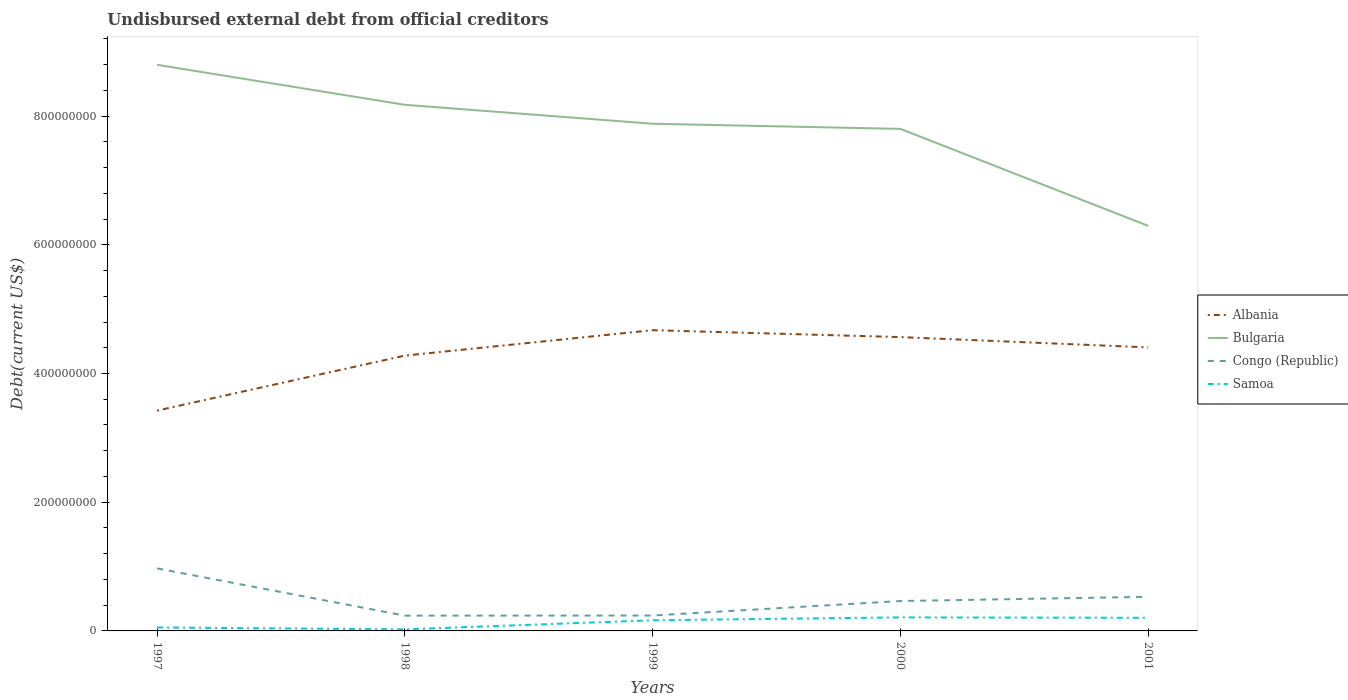Is the number of lines equal to the number of legend labels?
Your response must be concise. Yes. Across all years, what is the maximum total debt in Albania?
Provide a succinct answer. 3.42e+08. What is the total total debt in Bulgaria in the graph?
Make the answer very short. 6.22e+07. What is the difference between the highest and the second highest total debt in Albania?
Keep it short and to the point. 1.25e+08. What is the difference between the highest and the lowest total debt in Samoa?
Your answer should be compact. 3. How many lines are there?
Offer a very short reply. 4. How many years are there in the graph?
Provide a succinct answer. 5. Does the graph contain any zero values?
Your answer should be compact. No. Where does the legend appear in the graph?
Give a very brief answer. Center right. What is the title of the graph?
Make the answer very short. Undisbursed external debt from official creditors. Does "San Marino" appear as one of the legend labels in the graph?
Offer a terse response. No. What is the label or title of the Y-axis?
Provide a short and direct response. Debt(current US$). What is the Debt(current US$) of Albania in 1997?
Your response must be concise. 3.42e+08. What is the Debt(current US$) in Bulgaria in 1997?
Ensure brevity in your answer.  8.80e+08. What is the Debt(current US$) of Congo (Republic) in 1997?
Offer a terse response. 9.72e+07. What is the Debt(current US$) in Samoa in 1997?
Offer a very short reply. 5.40e+06. What is the Debt(current US$) of Albania in 1998?
Your answer should be very brief. 4.28e+08. What is the Debt(current US$) in Bulgaria in 1998?
Make the answer very short. 8.18e+08. What is the Debt(current US$) of Congo (Republic) in 1998?
Give a very brief answer. 2.37e+07. What is the Debt(current US$) in Samoa in 1998?
Your answer should be very brief. 2.42e+06. What is the Debt(current US$) of Albania in 1999?
Give a very brief answer. 4.67e+08. What is the Debt(current US$) in Bulgaria in 1999?
Make the answer very short. 7.88e+08. What is the Debt(current US$) in Congo (Republic) in 1999?
Your response must be concise. 2.40e+07. What is the Debt(current US$) in Samoa in 1999?
Offer a terse response. 1.66e+07. What is the Debt(current US$) of Albania in 2000?
Offer a terse response. 4.57e+08. What is the Debt(current US$) of Bulgaria in 2000?
Provide a succinct answer. 7.80e+08. What is the Debt(current US$) in Congo (Republic) in 2000?
Make the answer very short. 4.64e+07. What is the Debt(current US$) in Samoa in 2000?
Provide a short and direct response. 2.10e+07. What is the Debt(current US$) in Albania in 2001?
Ensure brevity in your answer.  4.41e+08. What is the Debt(current US$) in Bulgaria in 2001?
Your response must be concise. 6.29e+08. What is the Debt(current US$) in Congo (Republic) in 2001?
Offer a very short reply. 5.30e+07. What is the Debt(current US$) in Samoa in 2001?
Your answer should be compact. 2.04e+07. Across all years, what is the maximum Debt(current US$) of Albania?
Your answer should be very brief. 4.67e+08. Across all years, what is the maximum Debt(current US$) in Bulgaria?
Your answer should be compact. 8.80e+08. Across all years, what is the maximum Debt(current US$) in Congo (Republic)?
Give a very brief answer. 9.72e+07. Across all years, what is the maximum Debt(current US$) in Samoa?
Keep it short and to the point. 2.10e+07. Across all years, what is the minimum Debt(current US$) in Albania?
Provide a short and direct response. 3.42e+08. Across all years, what is the minimum Debt(current US$) in Bulgaria?
Keep it short and to the point. 6.29e+08. Across all years, what is the minimum Debt(current US$) of Congo (Republic)?
Make the answer very short. 2.37e+07. Across all years, what is the minimum Debt(current US$) in Samoa?
Keep it short and to the point. 2.42e+06. What is the total Debt(current US$) of Albania in the graph?
Provide a short and direct response. 2.13e+09. What is the total Debt(current US$) of Bulgaria in the graph?
Provide a short and direct response. 3.89e+09. What is the total Debt(current US$) in Congo (Republic) in the graph?
Make the answer very short. 2.44e+08. What is the total Debt(current US$) in Samoa in the graph?
Offer a terse response. 6.58e+07. What is the difference between the Debt(current US$) of Albania in 1997 and that in 1998?
Make the answer very short. -8.54e+07. What is the difference between the Debt(current US$) in Bulgaria in 1997 and that in 1998?
Keep it short and to the point. 6.22e+07. What is the difference between the Debt(current US$) of Congo (Republic) in 1997 and that in 1998?
Make the answer very short. 7.34e+07. What is the difference between the Debt(current US$) in Samoa in 1997 and that in 1998?
Your answer should be compact. 2.98e+06. What is the difference between the Debt(current US$) in Albania in 1997 and that in 1999?
Your answer should be compact. -1.25e+08. What is the difference between the Debt(current US$) in Bulgaria in 1997 and that in 1999?
Keep it short and to the point. 9.16e+07. What is the difference between the Debt(current US$) in Congo (Republic) in 1997 and that in 1999?
Your answer should be very brief. 7.32e+07. What is the difference between the Debt(current US$) in Samoa in 1997 and that in 1999?
Your answer should be compact. -1.12e+07. What is the difference between the Debt(current US$) in Albania in 1997 and that in 2000?
Provide a short and direct response. -1.14e+08. What is the difference between the Debt(current US$) of Bulgaria in 1997 and that in 2000?
Your response must be concise. 9.96e+07. What is the difference between the Debt(current US$) in Congo (Republic) in 1997 and that in 2000?
Keep it short and to the point. 5.07e+07. What is the difference between the Debt(current US$) of Samoa in 1997 and that in 2000?
Your response must be concise. -1.56e+07. What is the difference between the Debt(current US$) in Albania in 1997 and that in 2001?
Provide a short and direct response. -9.82e+07. What is the difference between the Debt(current US$) in Bulgaria in 1997 and that in 2001?
Offer a very short reply. 2.50e+08. What is the difference between the Debt(current US$) of Congo (Republic) in 1997 and that in 2001?
Offer a terse response. 4.41e+07. What is the difference between the Debt(current US$) in Samoa in 1997 and that in 2001?
Offer a very short reply. -1.50e+07. What is the difference between the Debt(current US$) in Albania in 1998 and that in 1999?
Your response must be concise. -3.95e+07. What is the difference between the Debt(current US$) of Bulgaria in 1998 and that in 1999?
Provide a succinct answer. 2.94e+07. What is the difference between the Debt(current US$) of Congo (Republic) in 1998 and that in 1999?
Ensure brevity in your answer.  -2.22e+05. What is the difference between the Debt(current US$) of Samoa in 1998 and that in 1999?
Keep it short and to the point. -1.41e+07. What is the difference between the Debt(current US$) of Albania in 1998 and that in 2000?
Your answer should be very brief. -2.88e+07. What is the difference between the Debt(current US$) in Bulgaria in 1998 and that in 2000?
Offer a very short reply. 3.74e+07. What is the difference between the Debt(current US$) of Congo (Republic) in 1998 and that in 2000?
Provide a succinct answer. -2.27e+07. What is the difference between the Debt(current US$) in Samoa in 1998 and that in 2000?
Provide a short and direct response. -1.86e+07. What is the difference between the Debt(current US$) in Albania in 1998 and that in 2001?
Ensure brevity in your answer.  -1.28e+07. What is the difference between the Debt(current US$) in Bulgaria in 1998 and that in 2001?
Give a very brief answer. 1.88e+08. What is the difference between the Debt(current US$) of Congo (Republic) in 1998 and that in 2001?
Offer a very short reply. -2.93e+07. What is the difference between the Debt(current US$) in Samoa in 1998 and that in 2001?
Ensure brevity in your answer.  -1.80e+07. What is the difference between the Debt(current US$) in Albania in 1999 and that in 2000?
Make the answer very short. 1.07e+07. What is the difference between the Debt(current US$) of Bulgaria in 1999 and that in 2000?
Give a very brief answer. 8.00e+06. What is the difference between the Debt(current US$) of Congo (Republic) in 1999 and that in 2000?
Your answer should be very brief. -2.25e+07. What is the difference between the Debt(current US$) of Samoa in 1999 and that in 2000?
Your answer should be compact. -4.47e+06. What is the difference between the Debt(current US$) of Albania in 1999 and that in 2001?
Ensure brevity in your answer.  2.67e+07. What is the difference between the Debt(current US$) of Bulgaria in 1999 and that in 2001?
Make the answer very short. 1.59e+08. What is the difference between the Debt(current US$) in Congo (Republic) in 1999 and that in 2001?
Your answer should be compact. -2.91e+07. What is the difference between the Debt(current US$) of Samoa in 1999 and that in 2001?
Make the answer very short. -3.84e+06. What is the difference between the Debt(current US$) in Albania in 2000 and that in 2001?
Offer a terse response. 1.60e+07. What is the difference between the Debt(current US$) of Bulgaria in 2000 and that in 2001?
Your response must be concise. 1.51e+08. What is the difference between the Debt(current US$) in Congo (Republic) in 2000 and that in 2001?
Give a very brief answer. -6.60e+06. What is the difference between the Debt(current US$) of Samoa in 2000 and that in 2001?
Your response must be concise. 6.26e+05. What is the difference between the Debt(current US$) of Albania in 1997 and the Debt(current US$) of Bulgaria in 1998?
Make the answer very short. -4.75e+08. What is the difference between the Debt(current US$) in Albania in 1997 and the Debt(current US$) in Congo (Republic) in 1998?
Your answer should be compact. 3.19e+08. What is the difference between the Debt(current US$) in Albania in 1997 and the Debt(current US$) in Samoa in 1998?
Ensure brevity in your answer.  3.40e+08. What is the difference between the Debt(current US$) in Bulgaria in 1997 and the Debt(current US$) in Congo (Republic) in 1998?
Keep it short and to the point. 8.56e+08. What is the difference between the Debt(current US$) in Bulgaria in 1997 and the Debt(current US$) in Samoa in 1998?
Your answer should be very brief. 8.77e+08. What is the difference between the Debt(current US$) in Congo (Republic) in 1997 and the Debt(current US$) in Samoa in 1998?
Make the answer very short. 9.48e+07. What is the difference between the Debt(current US$) in Albania in 1997 and the Debt(current US$) in Bulgaria in 1999?
Your answer should be very brief. -4.46e+08. What is the difference between the Debt(current US$) in Albania in 1997 and the Debt(current US$) in Congo (Republic) in 1999?
Make the answer very short. 3.18e+08. What is the difference between the Debt(current US$) of Albania in 1997 and the Debt(current US$) of Samoa in 1999?
Your response must be concise. 3.26e+08. What is the difference between the Debt(current US$) in Bulgaria in 1997 and the Debt(current US$) in Congo (Republic) in 1999?
Ensure brevity in your answer.  8.56e+08. What is the difference between the Debt(current US$) in Bulgaria in 1997 and the Debt(current US$) in Samoa in 1999?
Keep it short and to the point. 8.63e+08. What is the difference between the Debt(current US$) of Congo (Republic) in 1997 and the Debt(current US$) of Samoa in 1999?
Your response must be concise. 8.06e+07. What is the difference between the Debt(current US$) in Albania in 1997 and the Debt(current US$) in Bulgaria in 2000?
Keep it short and to the point. -4.38e+08. What is the difference between the Debt(current US$) of Albania in 1997 and the Debt(current US$) of Congo (Republic) in 2000?
Offer a terse response. 2.96e+08. What is the difference between the Debt(current US$) of Albania in 1997 and the Debt(current US$) of Samoa in 2000?
Provide a succinct answer. 3.21e+08. What is the difference between the Debt(current US$) in Bulgaria in 1997 and the Debt(current US$) in Congo (Republic) in 2000?
Your response must be concise. 8.33e+08. What is the difference between the Debt(current US$) in Bulgaria in 1997 and the Debt(current US$) in Samoa in 2000?
Provide a short and direct response. 8.59e+08. What is the difference between the Debt(current US$) of Congo (Republic) in 1997 and the Debt(current US$) of Samoa in 2000?
Make the answer very short. 7.61e+07. What is the difference between the Debt(current US$) in Albania in 1997 and the Debt(current US$) in Bulgaria in 2001?
Provide a succinct answer. -2.87e+08. What is the difference between the Debt(current US$) in Albania in 1997 and the Debt(current US$) in Congo (Republic) in 2001?
Ensure brevity in your answer.  2.89e+08. What is the difference between the Debt(current US$) in Albania in 1997 and the Debt(current US$) in Samoa in 2001?
Make the answer very short. 3.22e+08. What is the difference between the Debt(current US$) in Bulgaria in 1997 and the Debt(current US$) in Congo (Republic) in 2001?
Keep it short and to the point. 8.27e+08. What is the difference between the Debt(current US$) in Bulgaria in 1997 and the Debt(current US$) in Samoa in 2001?
Provide a short and direct response. 8.59e+08. What is the difference between the Debt(current US$) of Congo (Republic) in 1997 and the Debt(current US$) of Samoa in 2001?
Make the answer very short. 7.68e+07. What is the difference between the Debt(current US$) in Albania in 1998 and the Debt(current US$) in Bulgaria in 1999?
Your response must be concise. -3.60e+08. What is the difference between the Debt(current US$) of Albania in 1998 and the Debt(current US$) of Congo (Republic) in 1999?
Your answer should be compact. 4.04e+08. What is the difference between the Debt(current US$) of Albania in 1998 and the Debt(current US$) of Samoa in 1999?
Your response must be concise. 4.11e+08. What is the difference between the Debt(current US$) of Bulgaria in 1998 and the Debt(current US$) of Congo (Republic) in 1999?
Offer a very short reply. 7.94e+08. What is the difference between the Debt(current US$) of Bulgaria in 1998 and the Debt(current US$) of Samoa in 1999?
Offer a terse response. 8.01e+08. What is the difference between the Debt(current US$) in Congo (Republic) in 1998 and the Debt(current US$) in Samoa in 1999?
Provide a succinct answer. 7.18e+06. What is the difference between the Debt(current US$) in Albania in 1998 and the Debt(current US$) in Bulgaria in 2000?
Offer a terse response. -3.52e+08. What is the difference between the Debt(current US$) of Albania in 1998 and the Debt(current US$) of Congo (Republic) in 2000?
Your answer should be compact. 3.81e+08. What is the difference between the Debt(current US$) of Albania in 1998 and the Debt(current US$) of Samoa in 2000?
Your answer should be compact. 4.07e+08. What is the difference between the Debt(current US$) of Bulgaria in 1998 and the Debt(current US$) of Congo (Republic) in 2000?
Offer a very short reply. 7.71e+08. What is the difference between the Debt(current US$) in Bulgaria in 1998 and the Debt(current US$) in Samoa in 2000?
Your response must be concise. 7.97e+08. What is the difference between the Debt(current US$) of Congo (Republic) in 1998 and the Debt(current US$) of Samoa in 2000?
Your answer should be compact. 2.72e+06. What is the difference between the Debt(current US$) in Albania in 1998 and the Debt(current US$) in Bulgaria in 2001?
Ensure brevity in your answer.  -2.02e+08. What is the difference between the Debt(current US$) of Albania in 1998 and the Debt(current US$) of Congo (Republic) in 2001?
Offer a terse response. 3.75e+08. What is the difference between the Debt(current US$) of Albania in 1998 and the Debt(current US$) of Samoa in 2001?
Make the answer very short. 4.07e+08. What is the difference between the Debt(current US$) of Bulgaria in 1998 and the Debt(current US$) of Congo (Republic) in 2001?
Keep it short and to the point. 7.65e+08. What is the difference between the Debt(current US$) in Bulgaria in 1998 and the Debt(current US$) in Samoa in 2001?
Keep it short and to the point. 7.97e+08. What is the difference between the Debt(current US$) in Congo (Republic) in 1998 and the Debt(current US$) in Samoa in 2001?
Keep it short and to the point. 3.34e+06. What is the difference between the Debt(current US$) in Albania in 1999 and the Debt(current US$) in Bulgaria in 2000?
Offer a terse response. -3.13e+08. What is the difference between the Debt(current US$) of Albania in 1999 and the Debt(current US$) of Congo (Republic) in 2000?
Your response must be concise. 4.21e+08. What is the difference between the Debt(current US$) in Albania in 1999 and the Debt(current US$) in Samoa in 2000?
Your response must be concise. 4.46e+08. What is the difference between the Debt(current US$) of Bulgaria in 1999 and the Debt(current US$) of Congo (Republic) in 2000?
Provide a succinct answer. 7.42e+08. What is the difference between the Debt(current US$) in Bulgaria in 1999 and the Debt(current US$) in Samoa in 2000?
Provide a succinct answer. 7.67e+08. What is the difference between the Debt(current US$) of Congo (Republic) in 1999 and the Debt(current US$) of Samoa in 2000?
Give a very brief answer. 2.94e+06. What is the difference between the Debt(current US$) in Albania in 1999 and the Debt(current US$) in Bulgaria in 2001?
Ensure brevity in your answer.  -1.62e+08. What is the difference between the Debt(current US$) in Albania in 1999 and the Debt(current US$) in Congo (Republic) in 2001?
Your answer should be very brief. 4.14e+08. What is the difference between the Debt(current US$) in Albania in 1999 and the Debt(current US$) in Samoa in 2001?
Give a very brief answer. 4.47e+08. What is the difference between the Debt(current US$) of Bulgaria in 1999 and the Debt(current US$) of Congo (Republic) in 2001?
Your answer should be very brief. 7.35e+08. What is the difference between the Debt(current US$) in Bulgaria in 1999 and the Debt(current US$) in Samoa in 2001?
Give a very brief answer. 7.68e+08. What is the difference between the Debt(current US$) in Congo (Republic) in 1999 and the Debt(current US$) in Samoa in 2001?
Offer a very short reply. 3.56e+06. What is the difference between the Debt(current US$) in Albania in 2000 and the Debt(current US$) in Bulgaria in 2001?
Your answer should be compact. -1.73e+08. What is the difference between the Debt(current US$) of Albania in 2000 and the Debt(current US$) of Congo (Republic) in 2001?
Your answer should be compact. 4.04e+08. What is the difference between the Debt(current US$) in Albania in 2000 and the Debt(current US$) in Samoa in 2001?
Ensure brevity in your answer.  4.36e+08. What is the difference between the Debt(current US$) of Bulgaria in 2000 and the Debt(current US$) of Congo (Republic) in 2001?
Provide a succinct answer. 7.27e+08. What is the difference between the Debt(current US$) in Bulgaria in 2000 and the Debt(current US$) in Samoa in 2001?
Keep it short and to the point. 7.60e+08. What is the difference between the Debt(current US$) in Congo (Republic) in 2000 and the Debt(current US$) in Samoa in 2001?
Offer a very short reply. 2.60e+07. What is the average Debt(current US$) of Albania per year?
Your answer should be compact. 4.27e+08. What is the average Debt(current US$) in Bulgaria per year?
Offer a very short reply. 7.79e+08. What is the average Debt(current US$) of Congo (Republic) per year?
Offer a very short reply. 4.89e+07. What is the average Debt(current US$) in Samoa per year?
Offer a terse response. 1.32e+07. In the year 1997, what is the difference between the Debt(current US$) in Albania and Debt(current US$) in Bulgaria?
Make the answer very short. -5.37e+08. In the year 1997, what is the difference between the Debt(current US$) of Albania and Debt(current US$) of Congo (Republic)?
Offer a terse response. 2.45e+08. In the year 1997, what is the difference between the Debt(current US$) of Albania and Debt(current US$) of Samoa?
Make the answer very short. 3.37e+08. In the year 1997, what is the difference between the Debt(current US$) of Bulgaria and Debt(current US$) of Congo (Republic)?
Your answer should be compact. 7.83e+08. In the year 1997, what is the difference between the Debt(current US$) in Bulgaria and Debt(current US$) in Samoa?
Provide a short and direct response. 8.74e+08. In the year 1997, what is the difference between the Debt(current US$) in Congo (Republic) and Debt(current US$) in Samoa?
Offer a terse response. 9.18e+07. In the year 1998, what is the difference between the Debt(current US$) of Albania and Debt(current US$) of Bulgaria?
Your response must be concise. -3.90e+08. In the year 1998, what is the difference between the Debt(current US$) in Albania and Debt(current US$) in Congo (Republic)?
Your answer should be compact. 4.04e+08. In the year 1998, what is the difference between the Debt(current US$) of Albania and Debt(current US$) of Samoa?
Provide a succinct answer. 4.25e+08. In the year 1998, what is the difference between the Debt(current US$) of Bulgaria and Debt(current US$) of Congo (Republic)?
Keep it short and to the point. 7.94e+08. In the year 1998, what is the difference between the Debt(current US$) in Bulgaria and Debt(current US$) in Samoa?
Offer a terse response. 8.15e+08. In the year 1998, what is the difference between the Debt(current US$) of Congo (Republic) and Debt(current US$) of Samoa?
Make the answer very short. 2.13e+07. In the year 1999, what is the difference between the Debt(current US$) of Albania and Debt(current US$) of Bulgaria?
Your response must be concise. -3.21e+08. In the year 1999, what is the difference between the Debt(current US$) of Albania and Debt(current US$) of Congo (Republic)?
Offer a very short reply. 4.43e+08. In the year 1999, what is the difference between the Debt(current US$) in Albania and Debt(current US$) in Samoa?
Your answer should be compact. 4.51e+08. In the year 1999, what is the difference between the Debt(current US$) in Bulgaria and Debt(current US$) in Congo (Republic)?
Offer a terse response. 7.64e+08. In the year 1999, what is the difference between the Debt(current US$) of Bulgaria and Debt(current US$) of Samoa?
Your response must be concise. 7.72e+08. In the year 1999, what is the difference between the Debt(current US$) in Congo (Republic) and Debt(current US$) in Samoa?
Make the answer very short. 7.40e+06. In the year 2000, what is the difference between the Debt(current US$) of Albania and Debt(current US$) of Bulgaria?
Give a very brief answer. -3.24e+08. In the year 2000, what is the difference between the Debt(current US$) of Albania and Debt(current US$) of Congo (Republic)?
Give a very brief answer. 4.10e+08. In the year 2000, what is the difference between the Debt(current US$) in Albania and Debt(current US$) in Samoa?
Offer a terse response. 4.36e+08. In the year 2000, what is the difference between the Debt(current US$) of Bulgaria and Debt(current US$) of Congo (Republic)?
Provide a short and direct response. 7.34e+08. In the year 2000, what is the difference between the Debt(current US$) of Bulgaria and Debt(current US$) of Samoa?
Offer a very short reply. 7.59e+08. In the year 2000, what is the difference between the Debt(current US$) of Congo (Republic) and Debt(current US$) of Samoa?
Provide a short and direct response. 2.54e+07. In the year 2001, what is the difference between the Debt(current US$) in Albania and Debt(current US$) in Bulgaria?
Your answer should be compact. -1.89e+08. In the year 2001, what is the difference between the Debt(current US$) of Albania and Debt(current US$) of Congo (Republic)?
Your answer should be very brief. 3.88e+08. In the year 2001, what is the difference between the Debt(current US$) in Albania and Debt(current US$) in Samoa?
Provide a succinct answer. 4.20e+08. In the year 2001, what is the difference between the Debt(current US$) in Bulgaria and Debt(current US$) in Congo (Republic)?
Offer a very short reply. 5.76e+08. In the year 2001, what is the difference between the Debt(current US$) of Bulgaria and Debt(current US$) of Samoa?
Give a very brief answer. 6.09e+08. In the year 2001, what is the difference between the Debt(current US$) in Congo (Republic) and Debt(current US$) in Samoa?
Provide a succinct answer. 3.26e+07. What is the ratio of the Debt(current US$) in Albania in 1997 to that in 1998?
Make the answer very short. 0.8. What is the ratio of the Debt(current US$) of Bulgaria in 1997 to that in 1998?
Provide a succinct answer. 1.08. What is the ratio of the Debt(current US$) of Congo (Republic) in 1997 to that in 1998?
Your response must be concise. 4.09. What is the ratio of the Debt(current US$) of Samoa in 1997 to that in 1998?
Give a very brief answer. 2.23. What is the ratio of the Debt(current US$) in Albania in 1997 to that in 1999?
Provide a succinct answer. 0.73. What is the ratio of the Debt(current US$) of Bulgaria in 1997 to that in 1999?
Your answer should be very brief. 1.12. What is the ratio of the Debt(current US$) in Congo (Republic) in 1997 to that in 1999?
Your answer should be very brief. 4.06. What is the ratio of the Debt(current US$) in Samoa in 1997 to that in 1999?
Your answer should be very brief. 0.33. What is the ratio of the Debt(current US$) in Albania in 1997 to that in 2000?
Offer a very short reply. 0.75. What is the ratio of the Debt(current US$) in Bulgaria in 1997 to that in 2000?
Give a very brief answer. 1.13. What is the ratio of the Debt(current US$) of Congo (Republic) in 1997 to that in 2000?
Make the answer very short. 2.09. What is the ratio of the Debt(current US$) in Samoa in 1997 to that in 2000?
Make the answer very short. 0.26. What is the ratio of the Debt(current US$) in Albania in 1997 to that in 2001?
Your answer should be very brief. 0.78. What is the ratio of the Debt(current US$) in Bulgaria in 1997 to that in 2001?
Your answer should be compact. 1.4. What is the ratio of the Debt(current US$) in Congo (Republic) in 1997 to that in 2001?
Ensure brevity in your answer.  1.83. What is the ratio of the Debt(current US$) in Samoa in 1997 to that in 2001?
Your answer should be compact. 0.26. What is the ratio of the Debt(current US$) in Albania in 1998 to that in 1999?
Make the answer very short. 0.92. What is the ratio of the Debt(current US$) in Bulgaria in 1998 to that in 1999?
Offer a terse response. 1.04. What is the ratio of the Debt(current US$) in Congo (Republic) in 1998 to that in 1999?
Offer a terse response. 0.99. What is the ratio of the Debt(current US$) of Samoa in 1998 to that in 1999?
Give a very brief answer. 0.15. What is the ratio of the Debt(current US$) in Albania in 1998 to that in 2000?
Your response must be concise. 0.94. What is the ratio of the Debt(current US$) in Bulgaria in 1998 to that in 2000?
Ensure brevity in your answer.  1.05. What is the ratio of the Debt(current US$) of Congo (Republic) in 1998 to that in 2000?
Your answer should be very brief. 0.51. What is the ratio of the Debt(current US$) of Samoa in 1998 to that in 2000?
Give a very brief answer. 0.12. What is the ratio of the Debt(current US$) of Bulgaria in 1998 to that in 2001?
Offer a very short reply. 1.3. What is the ratio of the Debt(current US$) of Congo (Republic) in 1998 to that in 2001?
Give a very brief answer. 0.45. What is the ratio of the Debt(current US$) in Samoa in 1998 to that in 2001?
Offer a terse response. 0.12. What is the ratio of the Debt(current US$) in Albania in 1999 to that in 2000?
Give a very brief answer. 1.02. What is the ratio of the Debt(current US$) in Bulgaria in 1999 to that in 2000?
Provide a short and direct response. 1.01. What is the ratio of the Debt(current US$) in Congo (Republic) in 1999 to that in 2000?
Your response must be concise. 0.52. What is the ratio of the Debt(current US$) in Samoa in 1999 to that in 2000?
Ensure brevity in your answer.  0.79. What is the ratio of the Debt(current US$) of Albania in 1999 to that in 2001?
Give a very brief answer. 1.06. What is the ratio of the Debt(current US$) in Bulgaria in 1999 to that in 2001?
Provide a succinct answer. 1.25. What is the ratio of the Debt(current US$) of Congo (Republic) in 1999 to that in 2001?
Offer a terse response. 0.45. What is the ratio of the Debt(current US$) of Samoa in 1999 to that in 2001?
Give a very brief answer. 0.81. What is the ratio of the Debt(current US$) in Albania in 2000 to that in 2001?
Keep it short and to the point. 1.04. What is the ratio of the Debt(current US$) of Bulgaria in 2000 to that in 2001?
Give a very brief answer. 1.24. What is the ratio of the Debt(current US$) in Congo (Republic) in 2000 to that in 2001?
Keep it short and to the point. 0.88. What is the ratio of the Debt(current US$) of Samoa in 2000 to that in 2001?
Your response must be concise. 1.03. What is the difference between the highest and the second highest Debt(current US$) of Albania?
Keep it short and to the point. 1.07e+07. What is the difference between the highest and the second highest Debt(current US$) of Bulgaria?
Your answer should be very brief. 6.22e+07. What is the difference between the highest and the second highest Debt(current US$) of Congo (Republic)?
Provide a short and direct response. 4.41e+07. What is the difference between the highest and the second highest Debt(current US$) of Samoa?
Your response must be concise. 6.26e+05. What is the difference between the highest and the lowest Debt(current US$) in Albania?
Your answer should be very brief. 1.25e+08. What is the difference between the highest and the lowest Debt(current US$) in Bulgaria?
Your answer should be very brief. 2.50e+08. What is the difference between the highest and the lowest Debt(current US$) of Congo (Republic)?
Your response must be concise. 7.34e+07. What is the difference between the highest and the lowest Debt(current US$) of Samoa?
Give a very brief answer. 1.86e+07. 